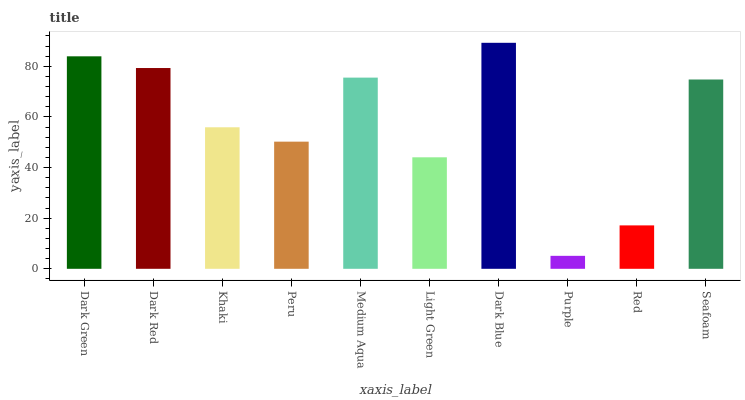Is Purple the minimum?
Answer yes or no. Yes. Is Dark Blue the maximum?
Answer yes or no. Yes. Is Dark Red the minimum?
Answer yes or no. No. Is Dark Red the maximum?
Answer yes or no. No. Is Dark Green greater than Dark Red?
Answer yes or no. Yes. Is Dark Red less than Dark Green?
Answer yes or no. Yes. Is Dark Red greater than Dark Green?
Answer yes or no. No. Is Dark Green less than Dark Red?
Answer yes or no. No. Is Seafoam the high median?
Answer yes or no. Yes. Is Khaki the low median?
Answer yes or no. Yes. Is Light Green the high median?
Answer yes or no. No. Is Purple the low median?
Answer yes or no. No. 